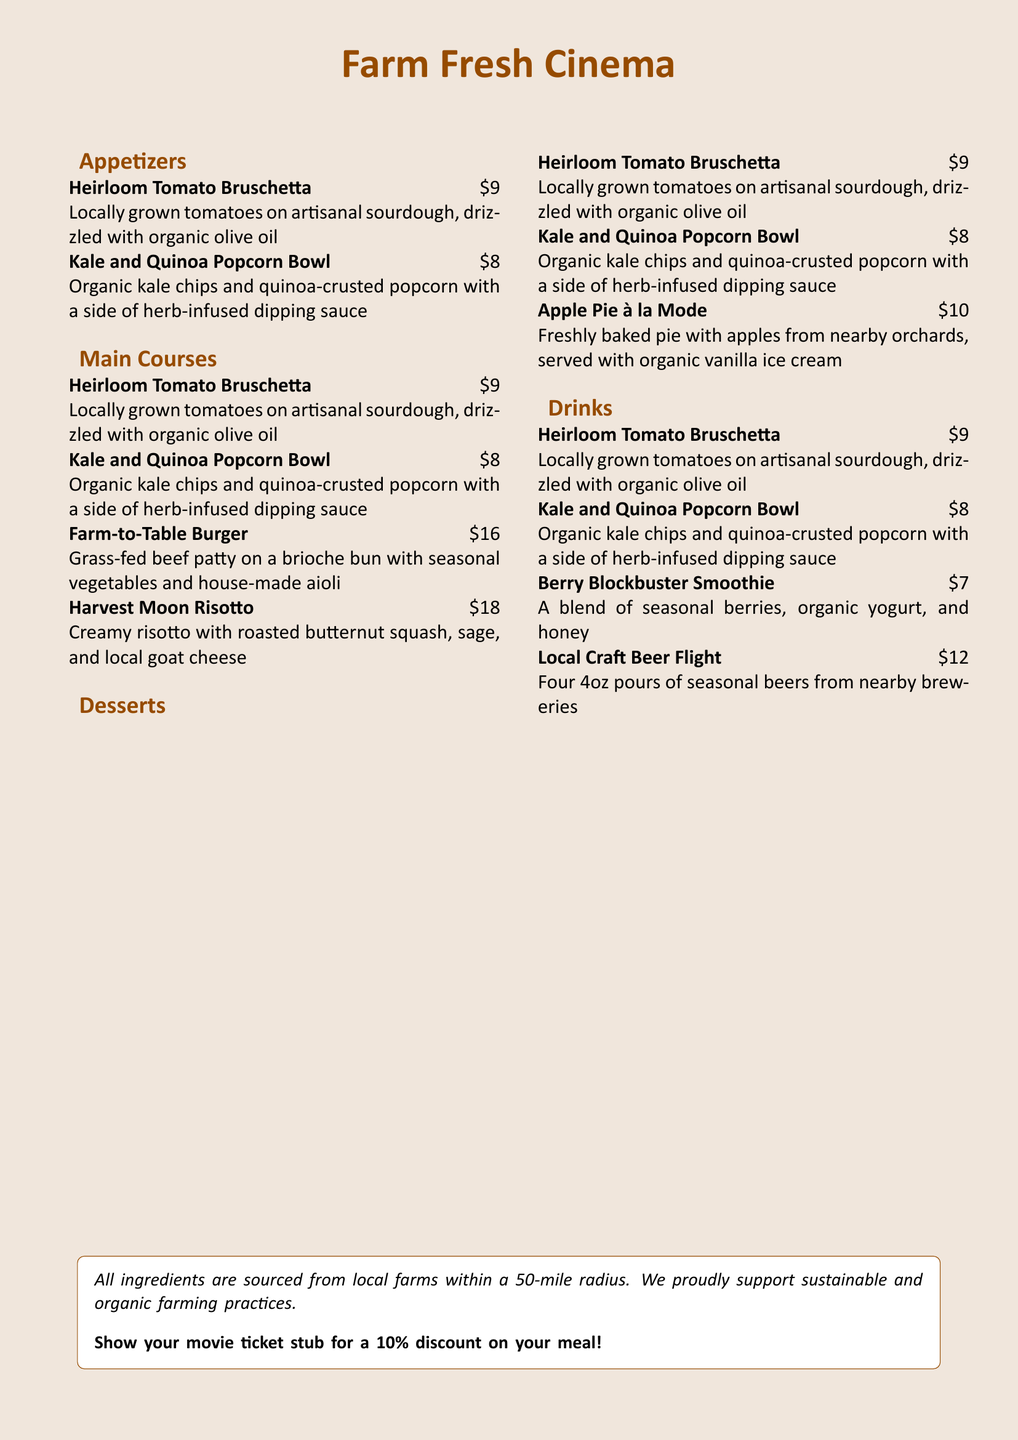What is the name of the bruschetta dish? The name of the bruschetta dish is stated as "Heirloom Tomato Bruschetta."
Answer: Heirloom Tomato Bruschetta What is the price of the Harvest Moon Risotto? The price for the Harvest Moon Risotto is clearly listed as $18.
Answer: $18 What type of cheese is used in the Harvest Moon Risotto? The type of cheese is specified as "local goat cheese."
Answer: local goat cheese How many ounces are included in the Local Craft Beer Flight? The Local Craft Beer Flight includes four 4oz pours, which is a total of 16oz.
Answer: four 4oz What discount can patrons receive by showing a movie ticket stub? The document mentions a 10% discount for showing a movie ticket stub.
Answer: 10% Which ingredient is in the Apple Pie à la Mode? The specific ingredient mentioned for the Apple Pie à la Mode is "apples from nearby orchards."
Answer: apples from nearby orchards What type of yogurt is used in the Berry Blockbuster Smoothie? The type of yogurt stated in the menu is "organic yogurt."
Answer: organic yogurt What is the primary focus of the seasonal menu? The primary focus of the seasonal menu is on ingredients sourced from local farms and sustainable options.
Answer: ingredients sourced from local farms Name one ingredient in the Kale and Quinoa Popcorn Bowl. The ingredient in the Kale and Quinoa Popcorn Bowl that is highlighted is "organic kale chips."
Answer: organic kale chips 